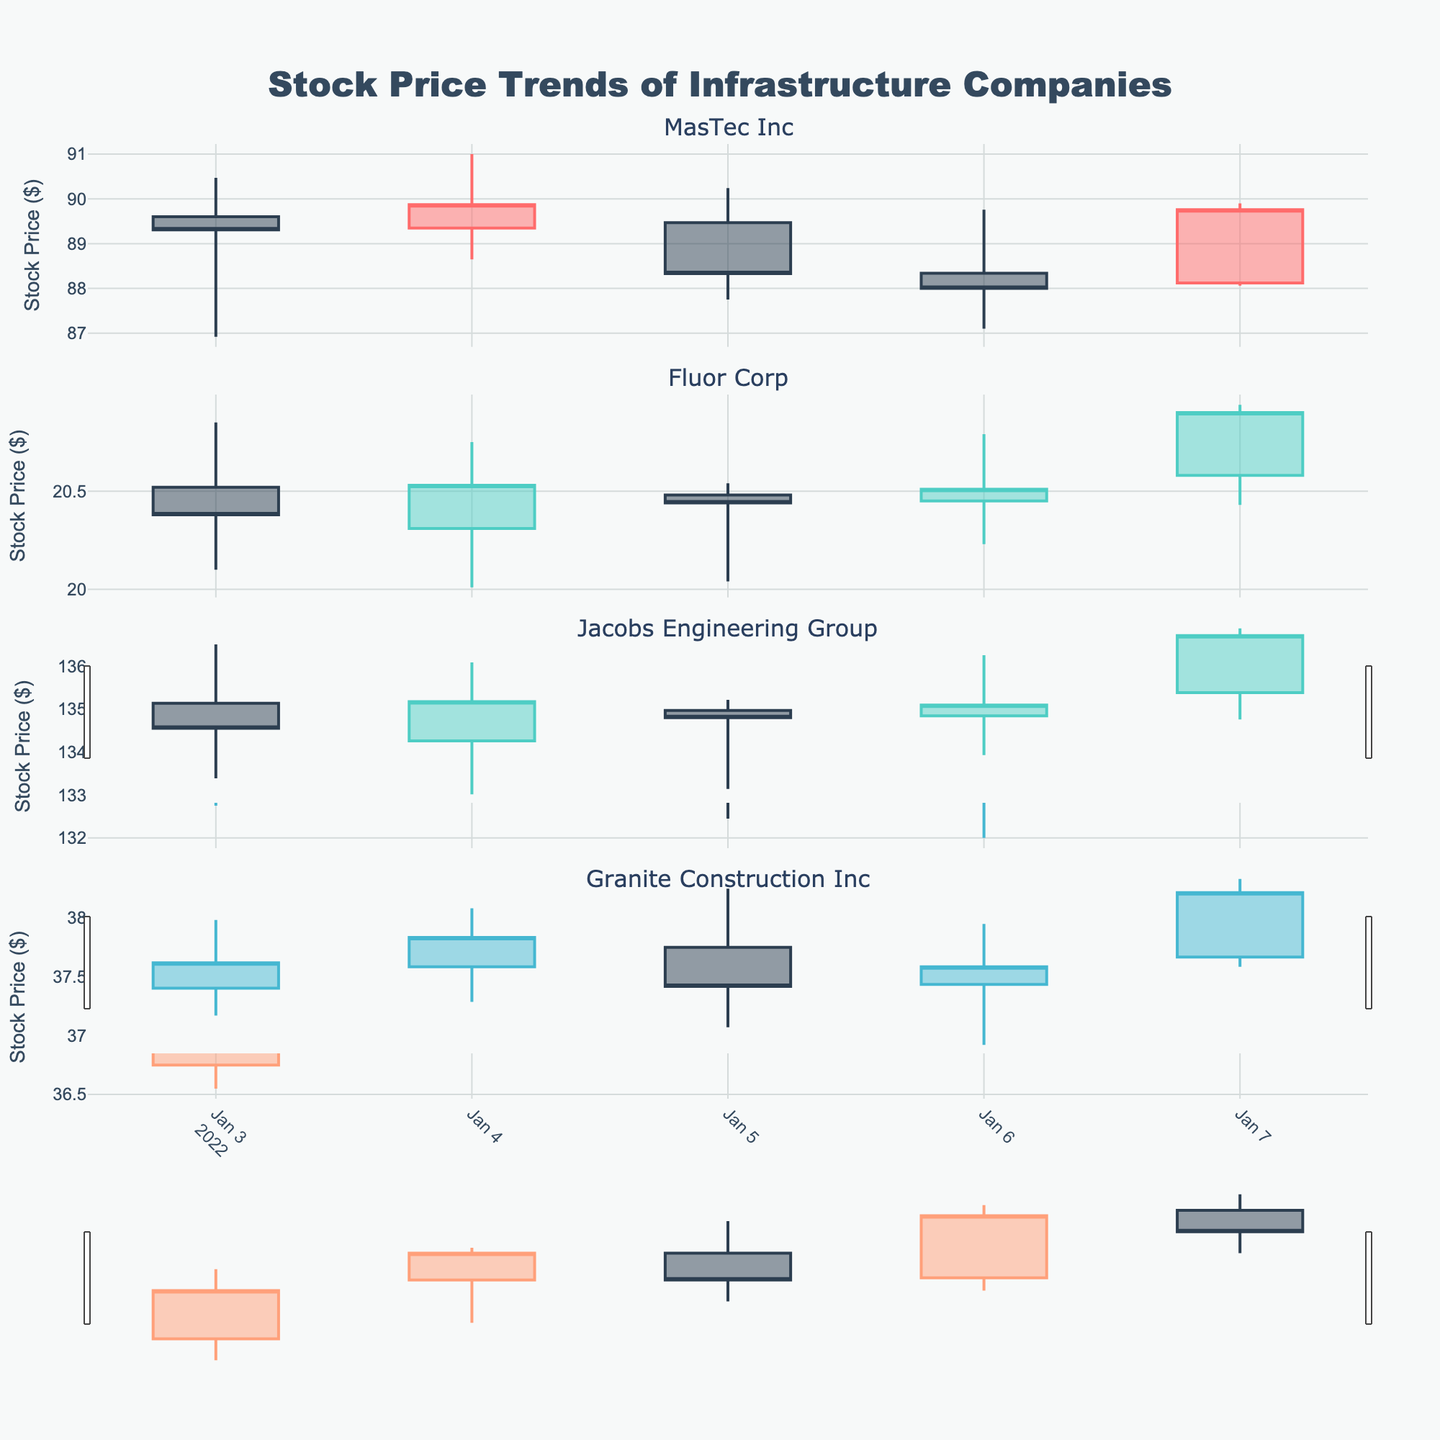What's the title of the figure? The title is usually at the top of the figure, and it logically describes the content being shown. From the code, we see that the title is "Stock Price Trends of Infrastructure Companies."
Answer: Stock Price Trends of Infrastructure Companies How many companies are represented in the figure? The plot is created using a subplot for each unique company from the data. The unique companies listed in the data are MasTec Inc, Fluor Corp, Jacobs Engineering Group, and Granite Construction Inc, making a total of 4 companies.
Answer: 4 Which company’s stock opened the highest in the data shown? By examining the highest opening prices from the candlestick plots, one can identify the company with the highest opening value. Jacobs Engineering Group has the highest opening price observed at 134.50 on January 5th.
Answer: Jacobs Engineering Group Is the closing price of MasTec Inc higher or lower than its opening price on January 5th? By looking at the candlestick for January 5th for MasTec Inc, where the closing value is below the opening value, the stock closed lower than it opened on that date.
Answer: Lower How did the stock price of Fluor Corp change from January 3rd to January 7th? Referring to the candlesticks for Fluor Corp from January 3rd to January 7th, we can see the stock opened at 20.52 and closed at 20.90, showing an overall increase.
Answer: Increased Which company exhibited the most significant increase in stock price within a single day? By examining each company's candlestick for the greatest difference between closing and opening prices, Jacobs Engineering Group increased significantly from 134.25 to 135.90 on January 7th, a difference of 1.65 dollars.
Answer: Jacobs Engineering Group What is the average closing price for Granite Construction Inc over the given dates? Add the closing prices for each date and divide by the number of dates: (37.20 + 37.55 + 37.30 + 37.90 + 37.75) / 5 = 37.54.
Answer: 37.54 Compare the closing prices of Jacobs Engineering Group and Granite Construction Inc on January 5th. Which one is higher? By comparing the plots, on January 5th, Jacobs Engineering Group closed at 133.50, while Granite Construction Inc closed at 37.30. Jacobs Engineering Group closed higher.
Answer: Jacobs Engineering Group Which company had the highest trading volume on January 4th? By looking at the volume bars at the bottom of the candlesticks for all companies, Fluor Corp had the highest volume of 1,200,000 on January 4th.
Answer: Fluor Corp Did any company's stock price decrease every day from January 3rd to January 7th? By examining the daily closing prices for each company, no company's stock consistently decreased every day between these dates.
Answer: No 